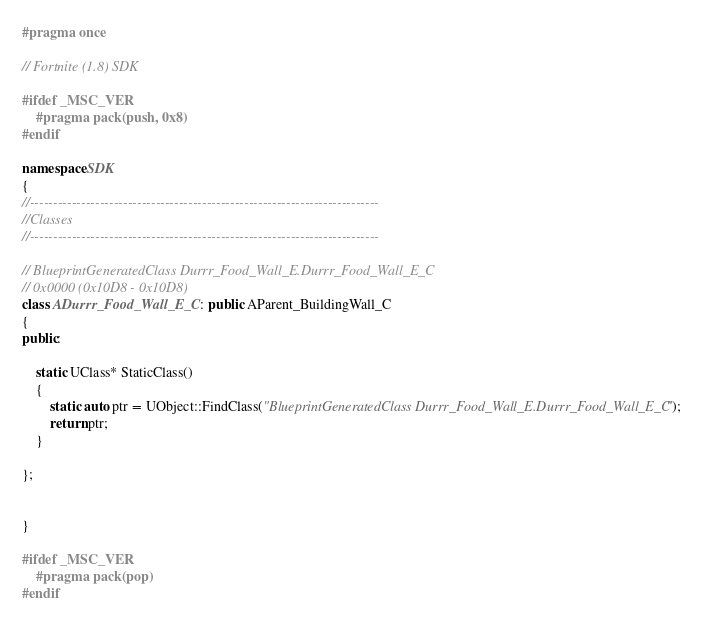<code> <loc_0><loc_0><loc_500><loc_500><_C++_>#pragma once

// Fortnite (1.8) SDK

#ifdef _MSC_VER
	#pragma pack(push, 0x8)
#endif

namespace SDK
{
//---------------------------------------------------------------------------
//Classes
//---------------------------------------------------------------------------

// BlueprintGeneratedClass Durrr_Food_Wall_E.Durrr_Food_Wall_E_C
// 0x0000 (0x10D8 - 0x10D8)
class ADurrr_Food_Wall_E_C : public AParent_BuildingWall_C
{
public:

	static UClass* StaticClass()
	{
		static auto ptr = UObject::FindClass("BlueprintGeneratedClass Durrr_Food_Wall_E.Durrr_Food_Wall_E_C");
		return ptr;
	}

};


}

#ifdef _MSC_VER
	#pragma pack(pop)
#endif
</code> 